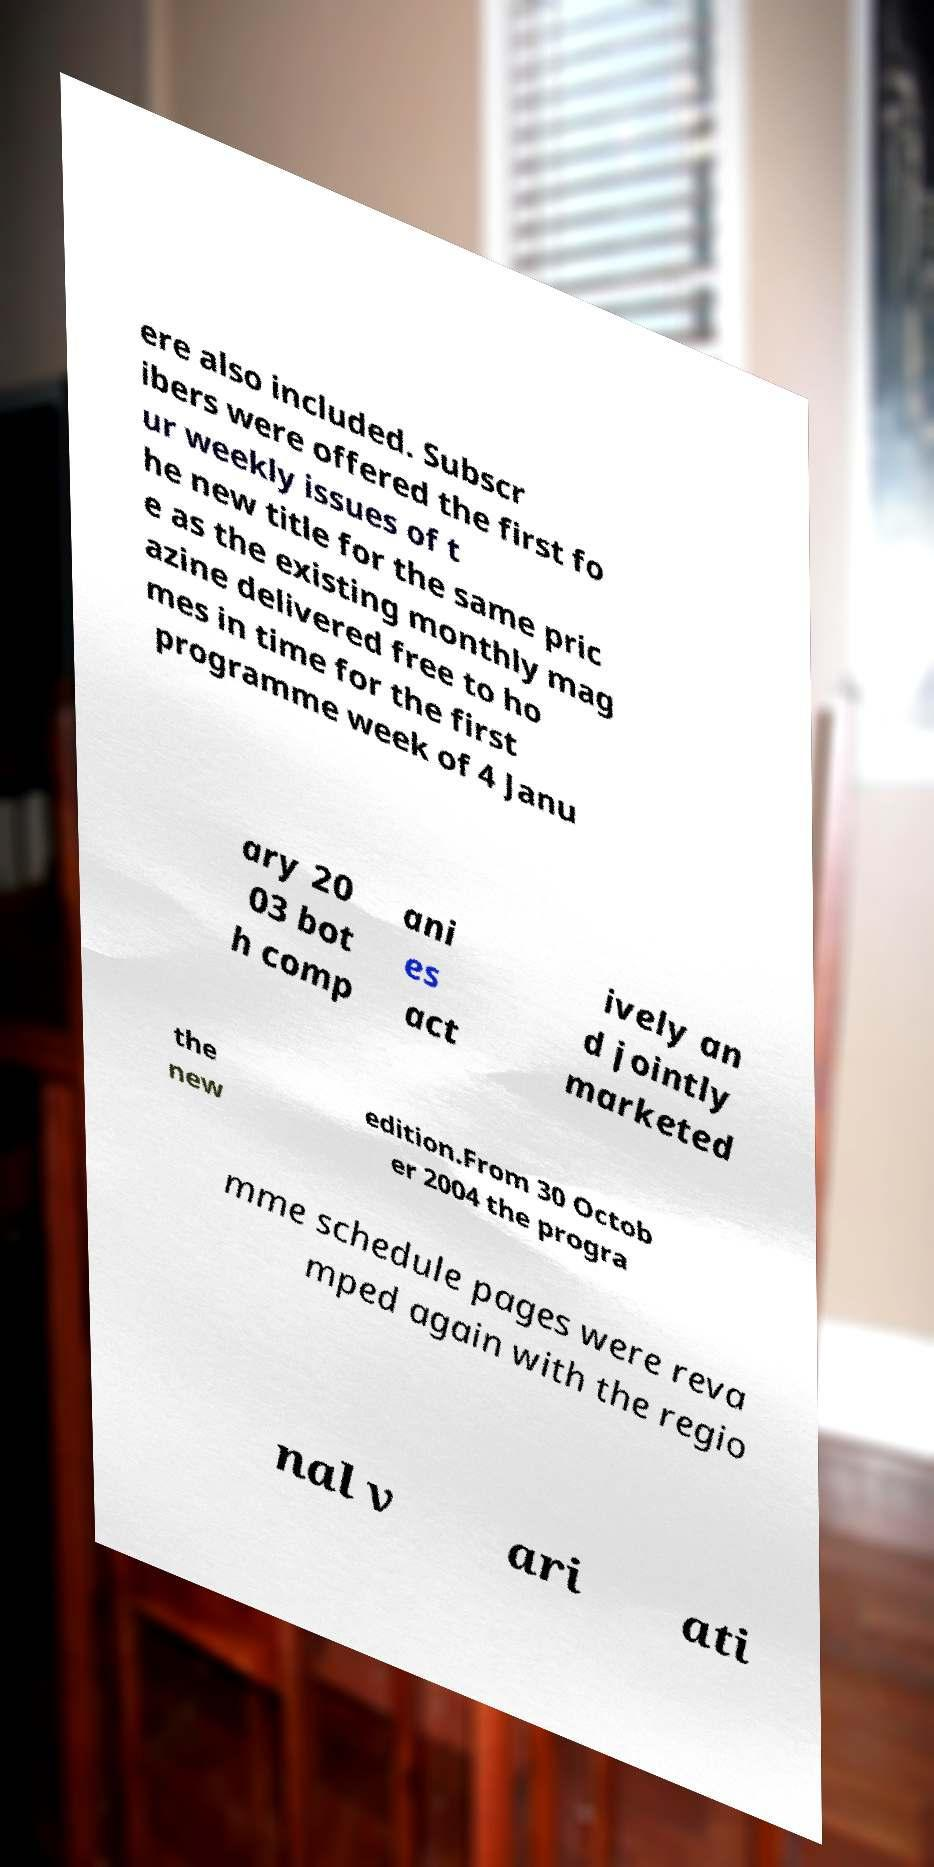Please read and relay the text visible in this image. What does it say? ere also included. Subscr ibers were offered the first fo ur weekly issues of t he new title for the same pric e as the existing monthly mag azine delivered free to ho mes in time for the first programme week of 4 Janu ary 20 03 bot h comp ani es act ively an d jointly marketed the new edition.From 30 Octob er 2004 the progra mme schedule pages were reva mped again with the regio nal v ari ati 